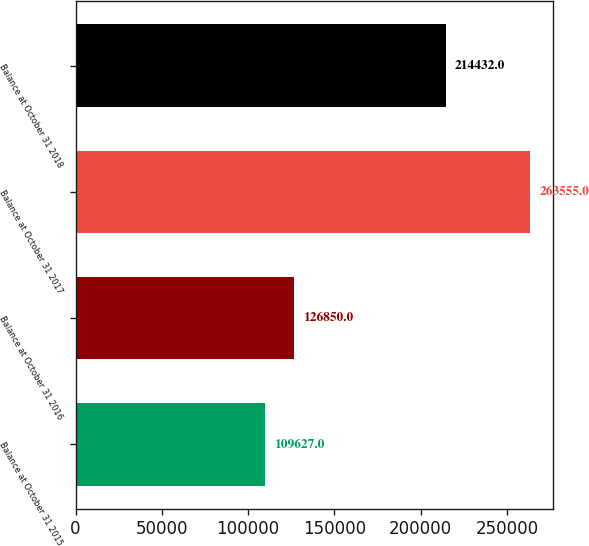Convert chart to OTSL. <chart><loc_0><loc_0><loc_500><loc_500><bar_chart><fcel>Balance at October 31 2015<fcel>Balance at October 31 2016<fcel>Balance at October 31 2017<fcel>Balance at October 31 2018<nl><fcel>109627<fcel>126850<fcel>263555<fcel>214432<nl></chart> 